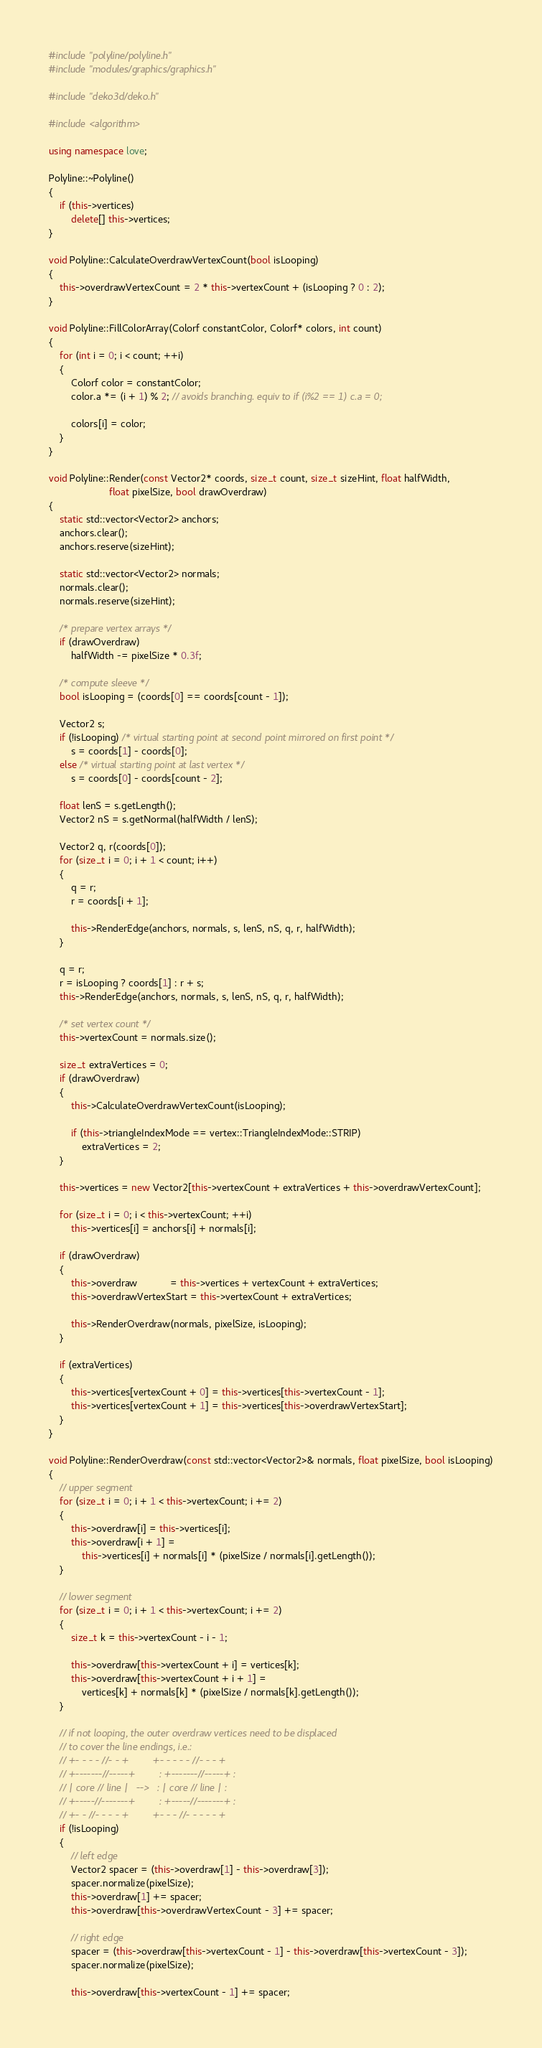<code> <loc_0><loc_0><loc_500><loc_500><_C++_>#include "polyline/polyline.h"
#include "modules/graphics/graphics.h"

#include "deko3d/deko.h"

#include <algorithm>

using namespace love;

Polyline::~Polyline()
{
    if (this->vertices)
        delete[] this->vertices;
}

void Polyline::CalculateOverdrawVertexCount(bool isLooping)
{
    this->overdrawVertexCount = 2 * this->vertexCount + (isLooping ? 0 : 2);
}

void Polyline::FillColorArray(Colorf constantColor, Colorf* colors, int count)
{
    for (int i = 0; i < count; ++i)
    {
        Colorf color = constantColor;
        color.a *= (i + 1) % 2; // avoids branching. equiv to if (i%2 == 1) c.a = 0;

        colors[i] = color;
    }
}

void Polyline::Render(const Vector2* coords, size_t count, size_t sizeHint, float halfWidth,
                      float pixelSize, bool drawOverdraw)
{
    static std::vector<Vector2> anchors;
    anchors.clear();
    anchors.reserve(sizeHint);

    static std::vector<Vector2> normals;
    normals.clear();
    normals.reserve(sizeHint);

    /* prepare vertex arrays */
    if (drawOverdraw)
        halfWidth -= pixelSize * 0.3f;

    /* compute sleeve */
    bool isLooping = (coords[0] == coords[count - 1]);

    Vector2 s;
    if (!isLooping) /* virtual starting point at second point mirrored on first point */
        s = coords[1] - coords[0];
    else /* virtual starting point at last vertex */
        s = coords[0] - coords[count - 2];

    float lenS = s.getLength();
    Vector2 nS = s.getNormal(halfWidth / lenS);

    Vector2 q, r(coords[0]);
    for (size_t i = 0; i + 1 < count; i++)
    {
        q = r;
        r = coords[i + 1];

        this->RenderEdge(anchors, normals, s, lenS, nS, q, r, halfWidth);
    }

    q = r;
    r = isLooping ? coords[1] : r + s;
    this->RenderEdge(anchors, normals, s, lenS, nS, q, r, halfWidth);

    /* set vertex count */
    this->vertexCount = normals.size();

    size_t extraVertices = 0;
    if (drawOverdraw)
    {
        this->CalculateOverdrawVertexCount(isLooping);

        if (this->triangleIndexMode == vertex::TriangleIndexMode::STRIP)
            extraVertices = 2;
    }

    this->vertices = new Vector2[this->vertexCount + extraVertices + this->overdrawVertexCount];

    for (size_t i = 0; i < this->vertexCount; ++i)
        this->vertices[i] = anchors[i] + normals[i];

    if (drawOverdraw)
    {
        this->overdraw            = this->vertices + vertexCount + extraVertices;
        this->overdrawVertexStart = this->vertexCount + extraVertices;

        this->RenderOverdraw(normals, pixelSize, isLooping);
    }

    if (extraVertices)
    {
        this->vertices[vertexCount + 0] = this->vertices[this->vertexCount - 1];
        this->vertices[vertexCount + 1] = this->vertices[this->overdrawVertexStart];
    }
}

void Polyline::RenderOverdraw(const std::vector<Vector2>& normals, float pixelSize, bool isLooping)
{
    // upper segment
    for (size_t i = 0; i + 1 < this->vertexCount; i += 2)
    {
        this->overdraw[i] = this->vertices[i];
        this->overdraw[i + 1] =
            this->vertices[i] + normals[i] * (pixelSize / normals[i].getLength());
    }

    // lower segment
    for (size_t i = 0; i + 1 < this->vertexCount; i += 2)
    {
        size_t k = this->vertexCount - i - 1;

        this->overdraw[this->vertexCount + i] = vertices[k];
        this->overdraw[this->vertexCount + i + 1] =
            vertices[k] + normals[k] * (pixelSize / normals[k].getLength());
    }

    // if not looping, the outer overdraw vertices need to be displaced
    // to cover the line endings, i.e.:
    // +- - - - //- - +         +- - - - - //- - - +
    // +-------//-----+         : +-------//-----+ :
    // | core // line |   -->   : | core // line | :
    // +-----//-------+         : +-----//-------+ :
    // +- - //- - - - +         +- - - //- - - - - +
    if (!isLooping)
    {
        // left edge
        Vector2 spacer = (this->overdraw[1] - this->overdraw[3]);
        spacer.normalize(pixelSize);
        this->overdraw[1] += spacer;
        this->overdraw[this->overdrawVertexCount - 3] += spacer;

        // right edge
        spacer = (this->overdraw[this->vertexCount - 1] - this->overdraw[this->vertexCount - 3]);
        spacer.normalize(pixelSize);

        this->overdraw[this->vertexCount - 1] += spacer;</code> 